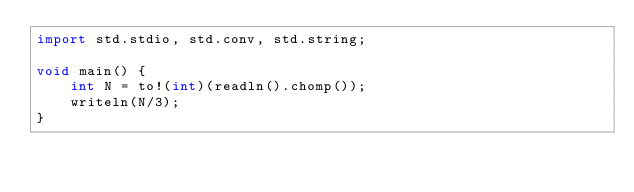<code> <loc_0><loc_0><loc_500><loc_500><_D_>import std.stdio, std.conv, std.string;

void main() {
	int N = to!(int)(readln().chomp());
	writeln(N/3);
}
</code> 